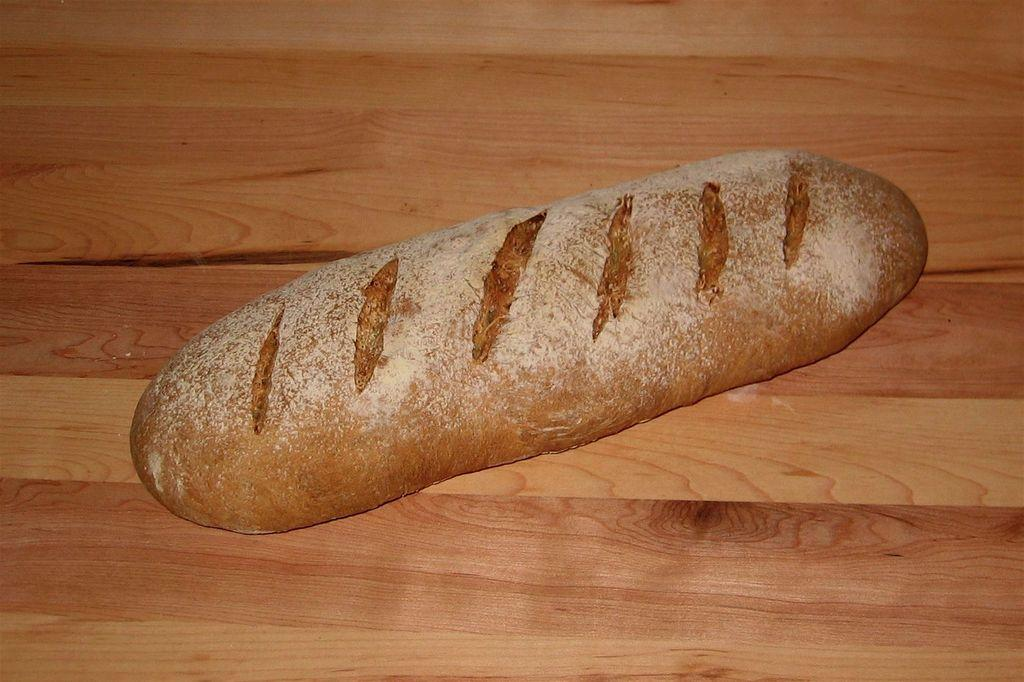What is the main subject of the image? There is a food item in the center of the image. Where is the food item located? The food item is on a table. What type of throat condition can be seen in the image? There is no throat condition present in the image; it features a food item on a table. What type of woman is depicted in the image? There is no woman depicted in the image; it features a food item on a table. 